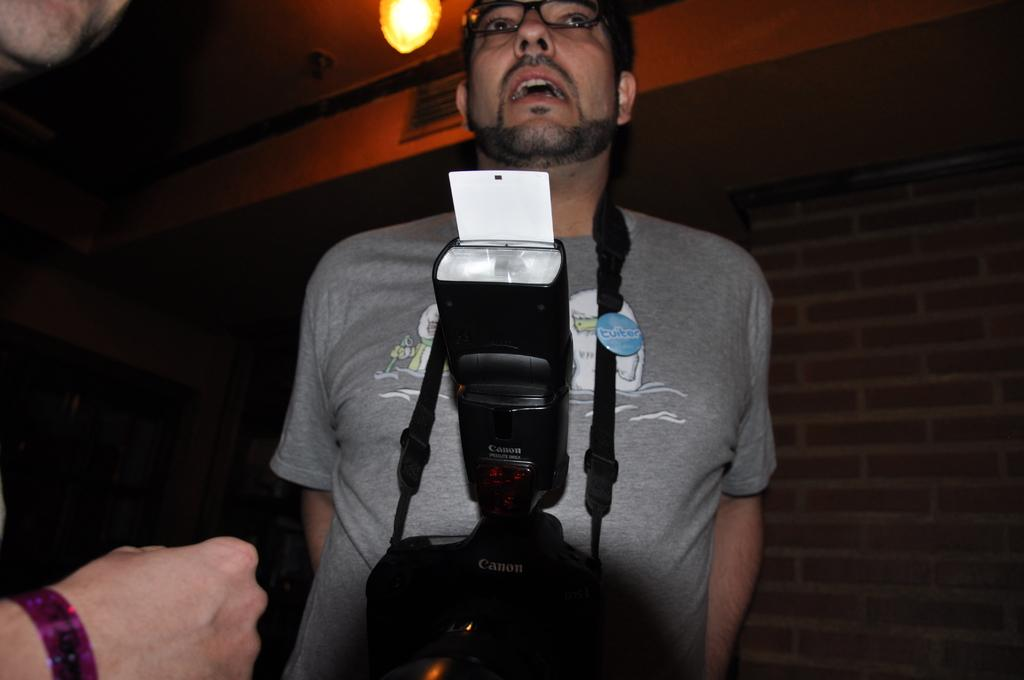Who is the main subject in the image? There is a man in the middle of the image. What is the man wearing? The man is wearing a camera with a belt. What can be seen at the top of the image? There is light visible at the top of the image. Can you describe the hand visible in the image? There is a hand of a person on the left side bottom of the image. What type of store is the man entering in the image? There is no store present in the image; it only features a man wearing a camera with a belt, light visible at the top, and a hand on the left side bottom. What message is the man conveying with his good-bye gesture in the image? There is no good-bye gesture visible in the image, and the man's message cannot be determined from the image alone. 